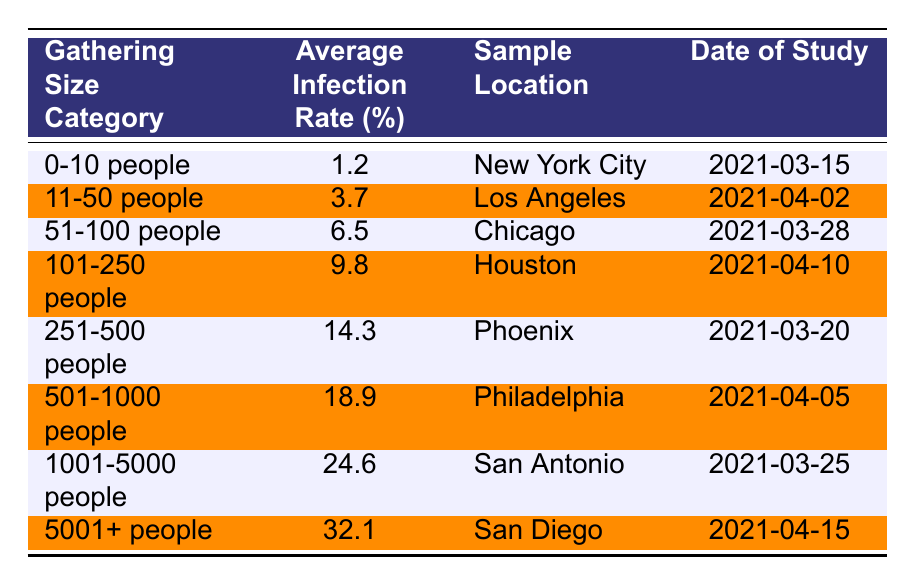What is the average infection rate for gatherings of 251-500 people? The table lists the average infection rate for the gathering size category "251-500 people" as 14.3%.
Answer: 14.3% Which city was the sample location for the gathering size category of 51-100 people? According to the table, the sample location for the "51-100 people" gathering size category is Chicago.
Answer: Chicago Is the average infection rate higher for gatherings of 1001-5000 people compared to gatherings of 501-1000 people? The average infection rate for "1001-5000 people" is 24.6% and for "501-1000 people" is 18.9%. Since 24.6% is greater than 18.9%, the statement is true.
Answer: Yes What is the difference in average infection rates between gatherings of 5001+ people and gatherings of 0-10 people? The average infection rate for "5001+ people" is 32.1% and for "0-10 people" is 1.2%. The difference is calculated as 32.1% - 1.2% = 30.9%.
Answer: 30.9% Which gathering size category has the highest infection rate, and what is that rate? The category "5001+ people" has the highest infection rate of 32.1% as per the data in the table.
Answer: 32.1% If we compare the average infection rates of gatherings of 11-50 people and 101-250 people, which one has a lower rate? The table shows that the average infection rate for "11-50 people" is 3.7% and for "101-250 people" is 9.8%. Since 3.7% is less than 9.8%, the "11-50 people" category has a lower average infection rate.
Answer: 11-50 people What is the trend in average infection rates as the size of gatherings increases in the table? The data indicates that as the gathering size category increases from "0-10 people" up to "5001+ people," the average infection rate consistently increases from 1.2% to 32.1%. This shows a clear trend of rising infection rates with larger gatherings.
Answer: Increasing trend Which date did the study on gatherings of 1001-5000 people take place? Referring to the table, the study on "1001-5000 people" occurred on March 25, 2021.
Answer: March 25, 2021 What was the average infection rate for the smallest gathering size category? The average infection rate for "0-10 people" is listed in the table as 1.2%.
Answer: 1.2% Is it true that all gathering size categories above 500 people have an average infection rate of more than 10%? Evaluating the table, the categories above 500 people (501-1000, 1001-5000, and 5001+) have rates of 18.9%, 24.6%, and 32.1% respectively. Yes, all have rates above 10%.
Answer: Yes 